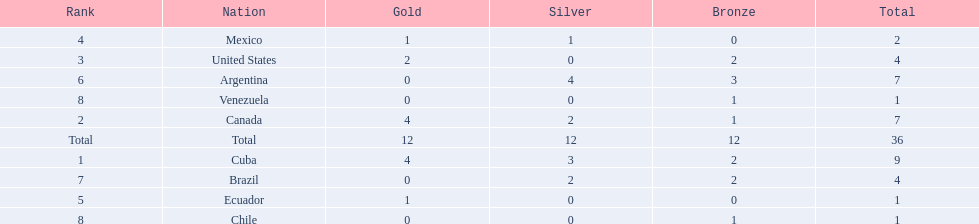What were all of the nations involved in the canoeing at the 2011 pan american games? Cuba, Canada, United States, Mexico, Ecuador, Argentina, Brazil, Chile, Venezuela, Total. Of these, which had a numbered rank? Cuba, Canada, United States, Mexico, Ecuador, Argentina, Brazil, Chile, Venezuela. From these, which had the highest number of bronze? Argentina. 